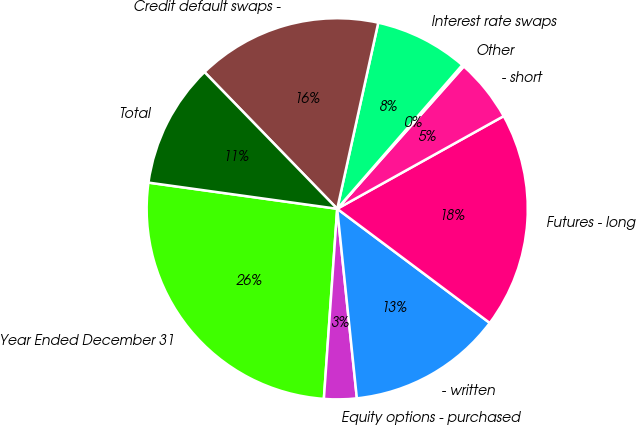Convert chart to OTSL. <chart><loc_0><loc_0><loc_500><loc_500><pie_chart><fcel>Year Ended December 31<fcel>Equity options - purchased<fcel>- written<fcel>Futures - long<fcel>- short<fcel>Other<fcel>Interest rate swaps<fcel>Credit default swaps -<fcel>Total<nl><fcel>26.08%<fcel>2.76%<fcel>13.13%<fcel>18.31%<fcel>5.35%<fcel>0.17%<fcel>7.94%<fcel>15.72%<fcel>10.54%<nl></chart> 